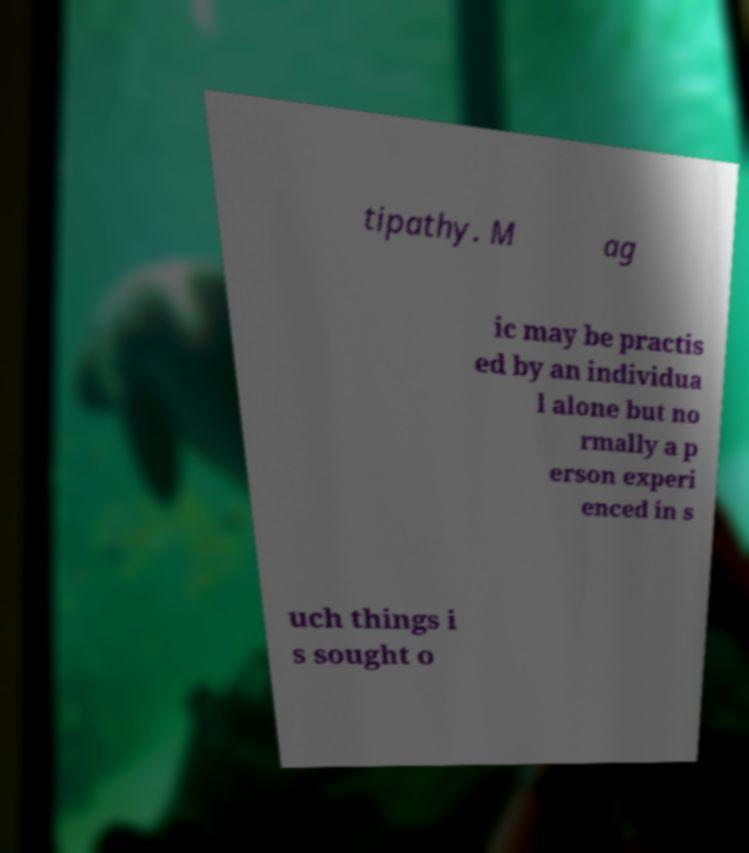Could you extract and type out the text from this image? tipathy. M ag ic may be practis ed by an individua l alone but no rmally a p erson experi enced in s uch things i s sought o 